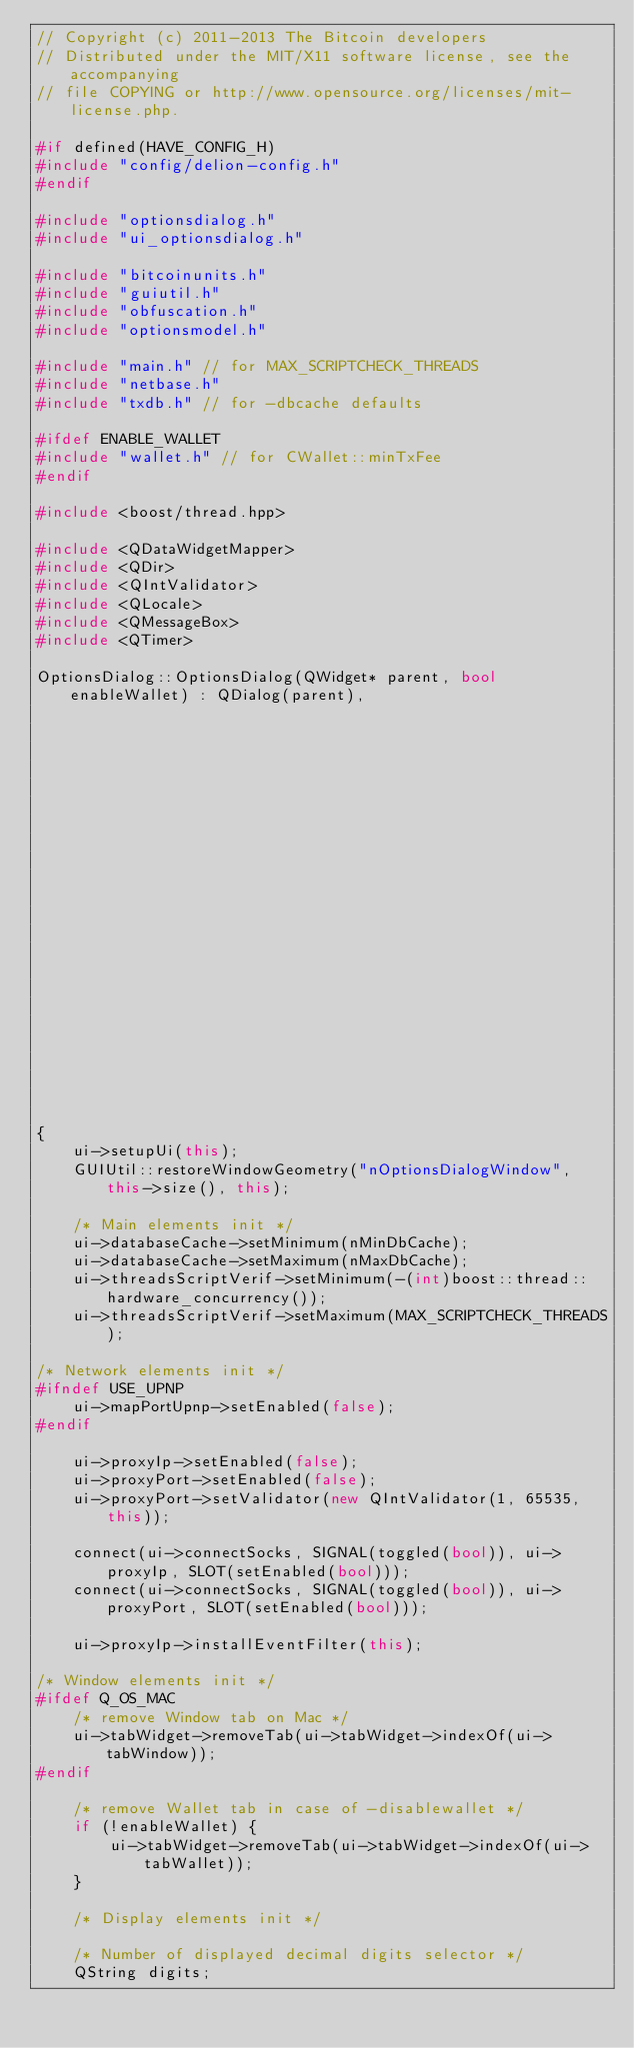Convert code to text. <code><loc_0><loc_0><loc_500><loc_500><_C++_>// Copyright (c) 2011-2013 The Bitcoin developers
// Distributed under the MIT/X11 software license, see the accompanying
// file COPYING or http://www.opensource.org/licenses/mit-license.php.

#if defined(HAVE_CONFIG_H)
#include "config/delion-config.h"
#endif

#include "optionsdialog.h"
#include "ui_optionsdialog.h"

#include "bitcoinunits.h"
#include "guiutil.h"
#include "obfuscation.h"
#include "optionsmodel.h"

#include "main.h" // for MAX_SCRIPTCHECK_THREADS
#include "netbase.h"
#include "txdb.h" // for -dbcache defaults

#ifdef ENABLE_WALLET
#include "wallet.h" // for CWallet::minTxFee
#endif

#include <boost/thread.hpp>

#include <QDataWidgetMapper>
#include <QDir>
#include <QIntValidator>
#include <QLocale>
#include <QMessageBox>
#include <QTimer>

OptionsDialog::OptionsDialog(QWidget* parent, bool enableWallet) : QDialog(parent),
                                                                   ui(new Ui::OptionsDialog),
                                                                   model(0),
                                                                   mapper(0),
                                                                   fProxyIpValid(true)
{
    ui->setupUi(this);
    GUIUtil::restoreWindowGeometry("nOptionsDialogWindow", this->size(), this);

    /* Main elements init */
    ui->databaseCache->setMinimum(nMinDbCache);
    ui->databaseCache->setMaximum(nMaxDbCache);
    ui->threadsScriptVerif->setMinimum(-(int)boost::thread::hardware_concurrency());
    ui->threadsScriptVerif->setMaximum(MAX_SCRIPTCHECK_THREADS);

/* Network elements init */
#ifndef USE_UPNP
    ui->mapPortUpnp->setEnabled(false);
#endif

    ui->proxyIp->setEnabled(false);
    ui->proxyPort->setEnabled(false);
    ui->proxyPort->setValidator(new QIntValidator(1, 65535, this));

    connect(ui->connectSocks, SIGNAL(toggled(bool)), ui->proxyIp, SLOT(setEnabled(bool)));
    connect(ui->connectSocks, SIGNAL(toggled(bool)), ui->proxyPort, SLOT(setEnabled(bool)));

    ui->proxyIp->installEventFilter(this);

/* Window elements init */
#ifdef Q_OS_MAC
    /* remove Window tab on Mac */
    ui->tabWidget->removeTab(ui->tabWidget->indexOf(ui->tabWindow));
#endif

    /* remove Wallet tab in case of -disablewallet */
    if (!enableWallet) {
        ui->tabWidget->removeTab(ui->tabWidget->indexOf(ui->tabWallet));
    }

    /* Display elements init */

    /* Number of displayed decimal digits selector */
    QString digits;</code> 